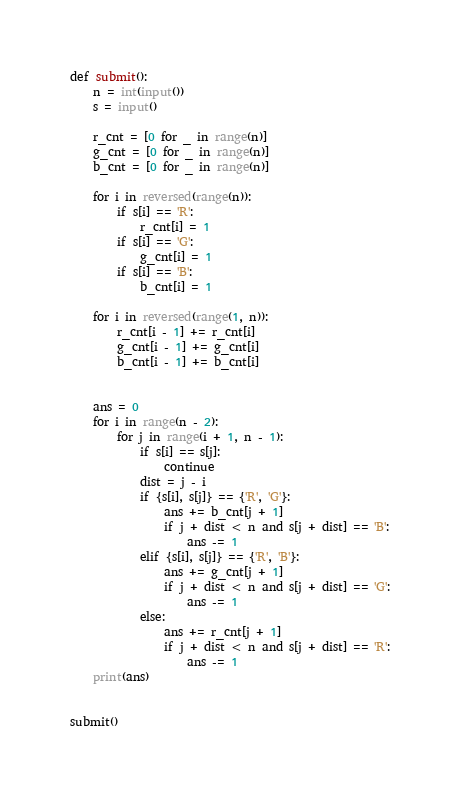<code> <loc_0><loc_0><loc_500><loc_500><_Python_>

def submit():
    n = int(input())
    s = input()

    r_cnt = [0 for _ in range(n)]
    g_cnt = [0 for _ in range(n)]
    b_cnt = [0 for _ in range(n)]

    for i in reversed(range(n)):
        if s[i] == 'R':
            r_cnt[i] = 1
        if s[i] == 'G':
            g_cnt[i] = 1
        if s[i] == 'B':
            b_cnt[i] = 1

    for i in reversed(range(1, n)):
        r_cnt[i - 1] += r_cnt[i]
        g_cnt[i - 1] += g_cnt[i]
        b_cnt[i - 1] += b_cnt[i]


    ans = 0
    for i in range(n - 2):
        for j in range(i + 1, n - 1):
            if s[i] == s[j]:
                continue
            dist = j - i
            if {s[i], s[j]} == {'R', 'G'}:
                ans += b_cnt[j + 1]
                if j + dist < n and s[j + dist] == 'B':
                    ans -= 1
            elif {s[i], s[j]} == {'R', 'B'}:
                ans += g_cnt[j + 1]
                if j + dist < n and s[j + dist] == 'G':
                    ans -= 1
            else:
                ans += r_cnt[j + 1]
                if j + dist < n and s[j + dist] == 'R':
                    ans -= 1
    print(ans)


submit()    
</code> 